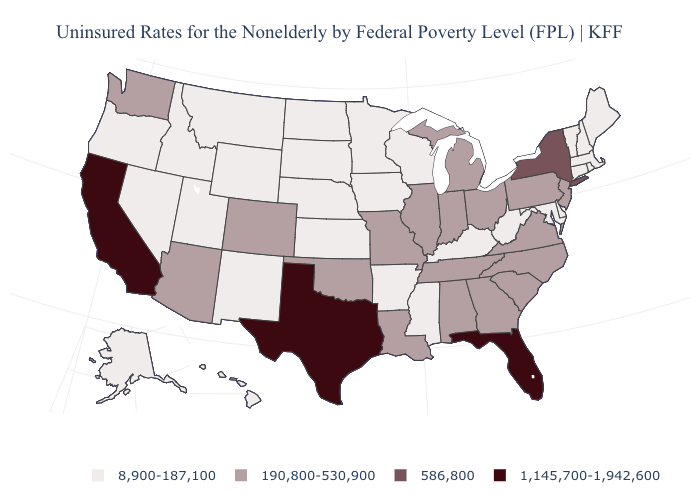Name the states that have a value in the range 8,900-187,100?
Answer briefly. Alaska, Arkansas, Connecticut, Delaware, Hawaii, Idaho, Iowa, Kansas, Kentucky, Maine, Maryland, Massachusetts, Minnesota, Mississippi, Montana, Nebraska, Nevada, New Hampshire, New Mexico, North Dakota, Oregon, Rhode Island, South Dakota, Utah, Vermont, West Virginia, Wisconsin, Wyoming. What is the value of Mississippi?
Be succinct. 8,900-187,100. Does Florida have a higher value than Montana?
Write a very short answer. Yes. Is the legend a continuous bar?
Give a very brief answer. No. What is the lowest value in states that border North Dakota?
Keep it brief. 8,900-187,100. What is the value of Arizona?
Concise answer only. 190,800-530,900. Does New Hampshire have the highest value in the Northeast?
Be succinct. No. What is the value of Vermont?
Short answer required. 8,900-187,100. Name the states that have a value in the range 586,800?
Give a very brief answer. New York. Name the states that have a value in the range 8,900-187,100?
Answer briefly. Alaska, Arkansas, Connecticut, Delaware, Hawaii, Idaho, Iowa, Kansas, Kentucky, Maine, Maryland, Massachusetts, Minnesota, Mississippi, Montana, Nebraska, Nevada, New Hampshire, New Mexico, North Dakota, Oregon, Rhode Island, South Dakota, Utah, Vermont, West Virginia, Wisconsin, Wyoming. Among the states that border Iowa , which have the lowest value?
Short answer required. Minnesota, Nebraska, South Dakota, Wisconsin. Does Nebraska have the lowest value in the USA?
Give a very brief answer. Yes. Name the states that have a value in the range 8,900-187,100?
Give a very brief answer. Alaska, Arkansas, Connecticut, Delaware, Hawaii, Idaho, Iowa, Kansas, Kentucky, Maine, Maryland, Massachusetts, Minnesota, Mississippi, Montana, Nebraska, Nevada, New Hampshire, New Mexico, North Dakota, Oregon, Rhode Island, South Dakota, Utah, Vermont, West Virginia, Wisconsin, Wyoming. Among the states that border Arizona , which have the highest value?
Short answer required. California. 